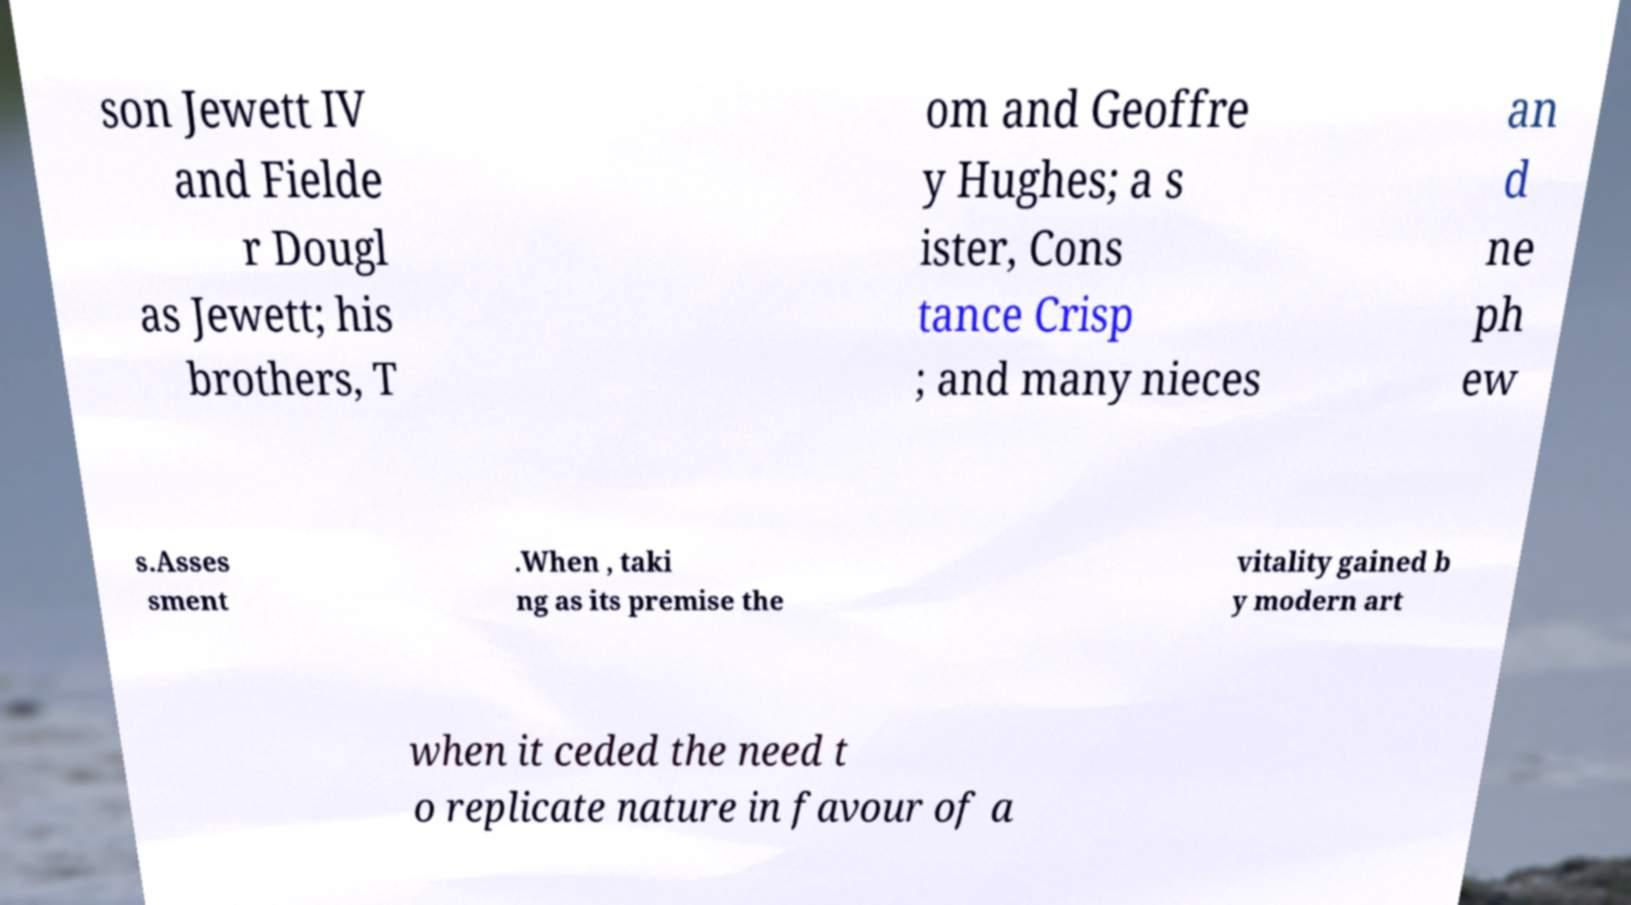Can you accurately transcribe the text from the provided image for me? son Jewett IV and Fielde r Dougl as Jewett; his brothers, T om and Geoffre y Hughes; a s ister, Cons tance Crisp ; and many nieces an d ne ph ew s.Asses sment .When , taki ng as its premise the vitality gained b y modern art when it ceded the need t o replicate nature in favour of a 